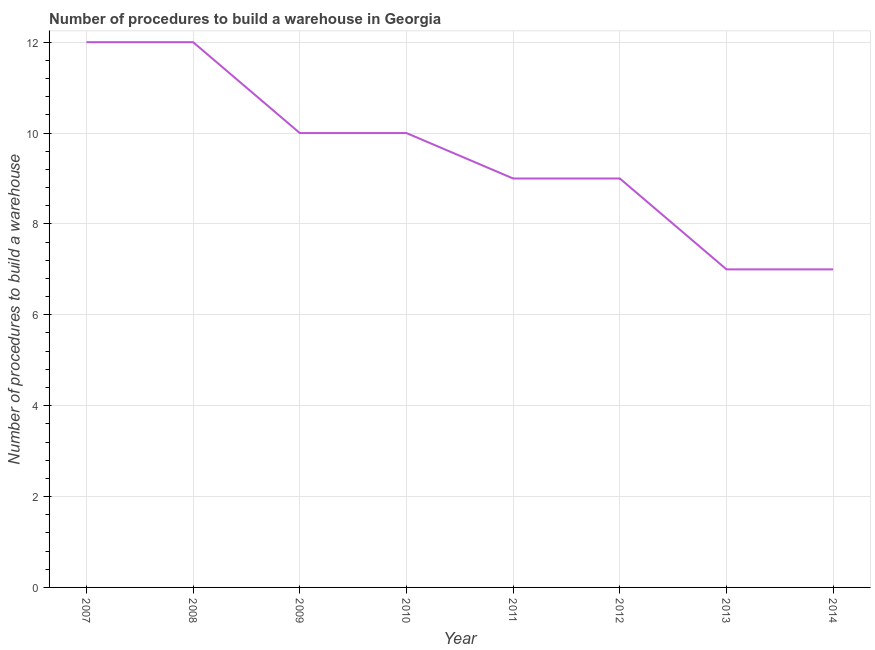What is the number of procedures to build a warehouse in 2009?
Your answer should be very brief. 10. Across all years, what is the maximum number of procedures to build a warehouse?
Offer a terse response. 12. Across all years, what is the minimum number of procedures to build a warehouse?
Keep it short and to the point. 7. In which year was the number of procedures to build a warehouse maximum?
Provide a short and direct response. 2007. What is the sum of the number of procedures to build a warehouse?
Give a very brief answer. 76. What is the difference between the number of procedures to build a warehouse in 2009 and 2011?
Provide a short and direct response. 1. What is the average number of procedures to build a warehouse per year?
Make the answer very short. 9.5. What is the median number of procedures to build a warehouse?
Make the answer very short. 9.5. What is the ratio of the number of procedures to build a warehouse in 2007 to that in 2008?
Offer a terse response. 1. Is the difference between the number of procedures to build a warehouse in 2007 and 2008 greater than the difference between any two years?
Offer a very short reply. No. What is the difference between the highest and the lowest number of procedures to build a warehouse?
Provide a short and direct response. 5. Does the number of procedures to build a warehouse monotonically increase over the years?
Keep it short and to the point. No. How many lines are there?
Provide a succinct answer. 1. Are the values on the major ticks of Y-axis written in scientific E-notation?
Your response must be concise. No. Does the graph contain any zero values?
Your answer should be very brief. No. What is the title of the graph?
Give a very brief answer. Number of procedures to build a warehouse in Georgia. What is the label or title of the X-axis?
Provide a short and direct response. Year. What is the label or title of the Y-axis?
Provide a succinct answer. Number of procedures to build a warehouse. What is the Number of procedures to build a warehouse of 2009?
Keep it short and to the point. 10. What is the Number of procedures to build a warehouse in 2014?
Your answer should be very brief. 7. What is the difference between the Number of procedures to build a warehouse in 2007 and 2013?
Provide a short and direct response. 5. What is the difference between the Number of procedures to build a warehouse in 2007 and 2014?
Provide a short and direct response. 5. What is the difference between the Number of procedures to build a warehouse in 2008 and 2014?
Ensure brevity in your answer.  5. What is the difference between the Number of procedures to build a warehouse in 2009 and 2010?
Keep it short and to the point. 0. What is the difference between the Number of procedures to build a warehouse in 2009 and 2011?
Offer a very short reply. 1. What is the difference between the Number of procedures to build a warehouse in 2009 and 2014?
Ensure brevity in your answer.  3. What is the difference between the Number of procedures to build a warehouse in 2010 and 2012?
Your answer should be very brief. 1. What is the difference between the Number of procedures to build a warehouse in 2010 and 2014?
Ensure brevity in your answer.  3. What is the difference between the Number of procedures to build a warehouse in 2011 and 2014?
Provide a succinct answer. 2. What is the difference between the Number of procedures to build a warehouse in 2012 and 2013?
Your answer should be very brief. 2. What is the difference between the Number of procedures to build a warehouse in 2012 and 2014?
Your answer should be compact. 2. What is the difference between the Number of procedures to build a warehouse in 2013 and 2014?
Provide a succinct answer. 0. What is the ratio of the Number of procedures to build a warehouse in 2007 to that in 2008?
Offer a terse response. 1. What is the ratio of the Number of procedures to build a warehouse in 2007 to that in 2010?
Keep it short and to the point. 1.2. What is the ratio of the Number of procedures to build a warehouse in 2007 to that in 2011?
Keep it short and to the point. 1.33. What is the ratio of the Number of procedures to build a warehouse in 2007 to that in 2012?
Your answer should be very brief. 1.33. What is the ratio of the Number of procedures to build a warehouse in 2007 to that in 2013?
Give a very brief answer. 1.71. What is the ratio of the Number of procedures to build a warehouse in 2007 to that in 2014?
Offer a terse response. 1.71. What is the ratio of the Number of procedures to build a warehouse in 2008 to that in 2009?
Offer a very short reply. 1.2. What is the ratio of the Number of procedures to build a warehouse in 2008 to that in 2010?
Your answer should be very brief. 1.2. What is the ratio of the Number of procedures to build a warehouse in 2008 to that in 2011?
Give a very brief answer. 1.33. What is the ratio of the Number of procedures to build a warehouse in 2008 to that in 2012?
Your answer should be very brief. 1.33. What is the ratio of the Number of procedures to build a warehouse in 2008 to that in 2013?
Offer a very short reply. 1.71. What is the ratio of the Number of procedures to build a warehouse in 2008 to that in 2014?
Offer a terse response. 1.71. What is the ratio of the Number of procedures to build a warehouse in 2009 to that in 2011?
Offer a terse response. 1.11. What is the ratio of the Number of procedures to build a warehouse in 2009 to that in 2012?
Offer a very short reply. 1.11. What is the ratio of the Number of procedures to build a warehouse in 2009 to that in 2013?
Provide a short and direct response. 1.43. What is the ratio of the Number of procedures to build a warehouse in 2009 to that in 2014?
Provide a succinct answer. 1.43. What is the ratio of the Number of procedures to build a warehouse in 2010 to that in 2011?
Provide a short and direct response. 1.11. What is the ratio of the Number of procedures to build a warehouse in 2010 to that in 2012?
Ensure brevity in your answer.  1.11. What is the ratio of the Number of procedures to build a warehouse in 2010 to that in 2013?
Your answer should be very brief. 1.43. What is the ratio of the Number of procedures to build a warehouse in 2010 to that in 2014?
Provide a short and direct response. 1.43. What is the ratio of the Number of procedures to build a warehouse in 2011 to that in 2013?
Offer a terse response. 1.29. What is the ratio of the Number of procedures to build a warehouse in 2011 to that in 2014?
Offer a very short reply. 1.29. What is the ratio of the Number of procedures to build a warehouse in 2012 to that in 2013?
Your answer should be very brief. 1.29. What is the ratio of the Number of procedures to build a warehouse in 2012 to that in 2014?
Your response must be concise. 1.29. What is the ratio of the Number of procedures to build a warehouse in 2013 to that in 2014?
Your answer should be compact. 1. 